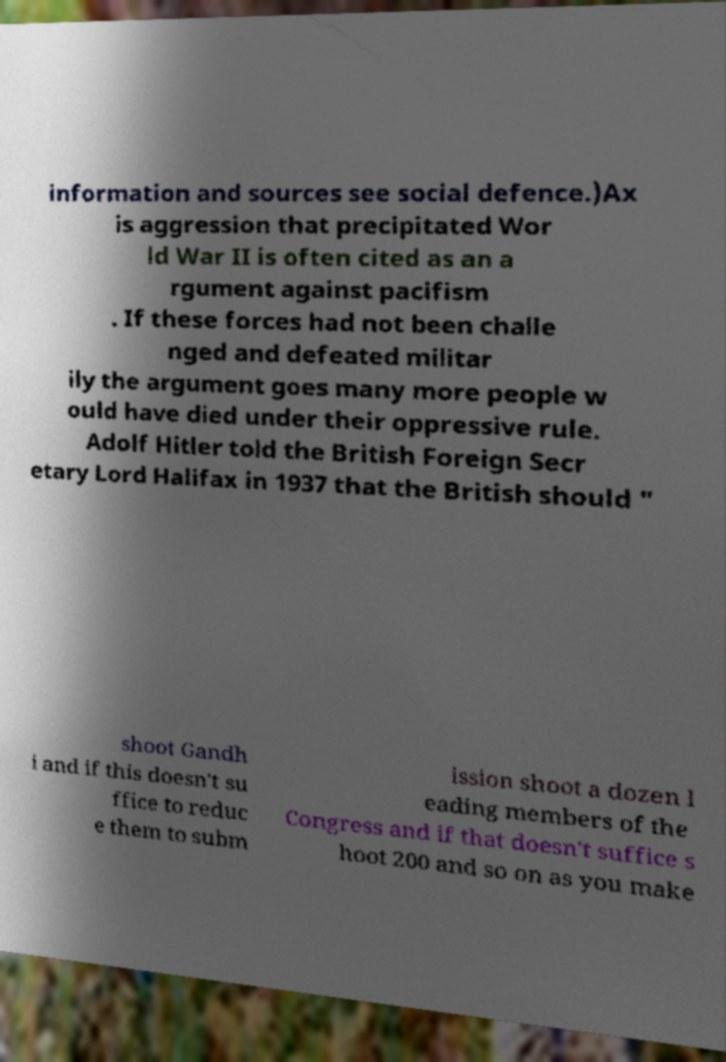Can you read and provide the text displayed in the image?This photo seems to have some interesting text. Can you extract and type it out for me? information and sources see social defence.)Ax is aggression that precipitated Wor ld War II is often cited as an a rgument against pacifism . If these forces had not been challe nged and defeated militar ily the argument goes many more people w ould have died under their oppressive rule. Adolf Hitler told the British Foreign Secr etary Lord Halifax in 1937 that the British should " shoot Gandh i and if this doesn't su ffice to reduc e them to subm ission shoot a dozen l eading members of the Congress and if that doesn't suffice s hoot 200 and so on as you make 